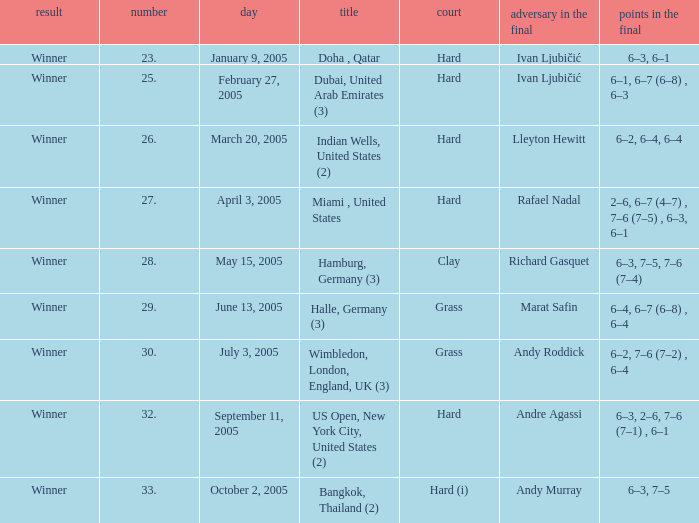Andy Roddick is the opponent in the final on what surface? Grass. 